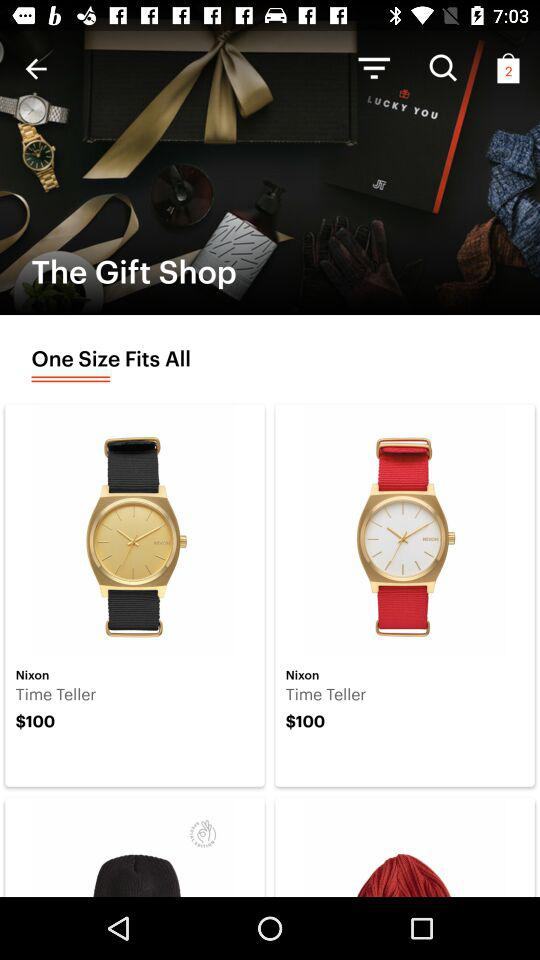How many items are in the bag? There are 2 items in the bag. 